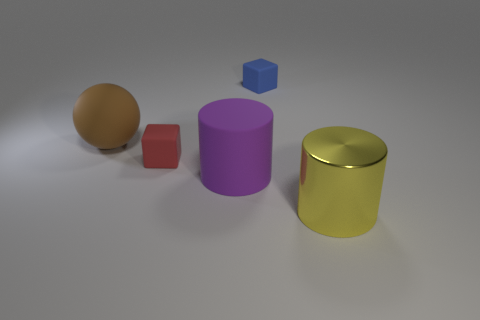Add 3 large brown rubber spheres. How many objects exist? 8 Subtract all spheres. How many objects are left? 4 Add 2 matte things. How many matte things are left? 6 Add 1 large gray balls. How many large gray balls exist? 1 Subtract 1 yellow cylinders. How many objects are left? 4 Subtract all red rubber things. Subtract all small rubber cubes. How many objects are left? 2 